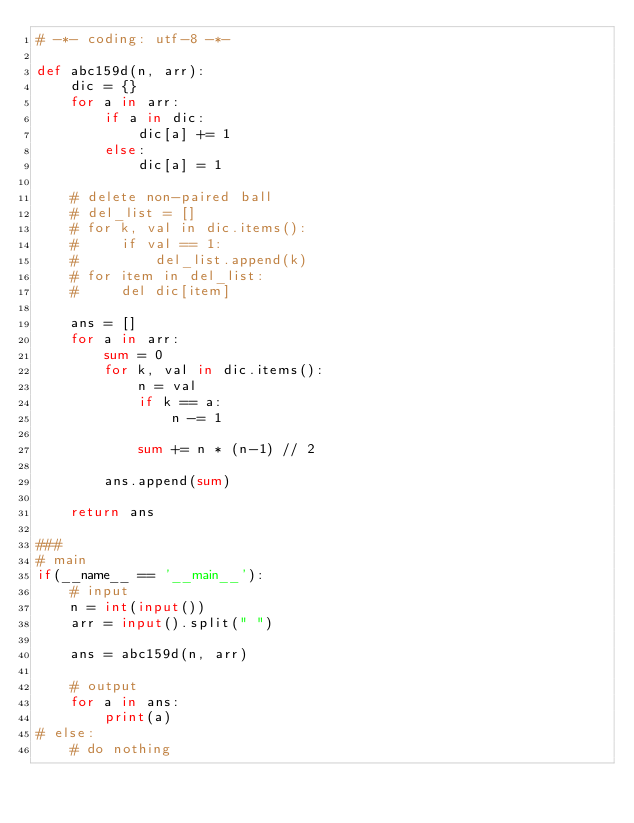Convert code to text. <code><loc_0><loc_0><loc_500><loc_500><_Python_># -*- coding: utf-8 -*-

def abc159d(n, arr):
    dic = {}
    for a in arr:
        if a in dic:
            dic[a] += 1
        else:
            dic[a] = 1
    
    # delete non-paired ball
    # del_list = []
    # for k, val in dic.items():
    #     if val == 1:
    #         del_list.append(k)
    # for item in del_list:
    #     del dic[item]

    ans = []
    for a in arr:
        sum = 0
        for k, val in dic.items():
            n = val
            if k == a:
                n -= 1

            sum += n * (n-1) // 2

        ans.append(sum)

    return ans

###
# main
if(__name__ == '__main__'):
    # input
    n = int(input())
    arr = input().split(" ")
    
    ans = abc159d(n, arr)
    
    # output
    for a in ans:
        print(a)
# else:
    # do nothing
</code> 